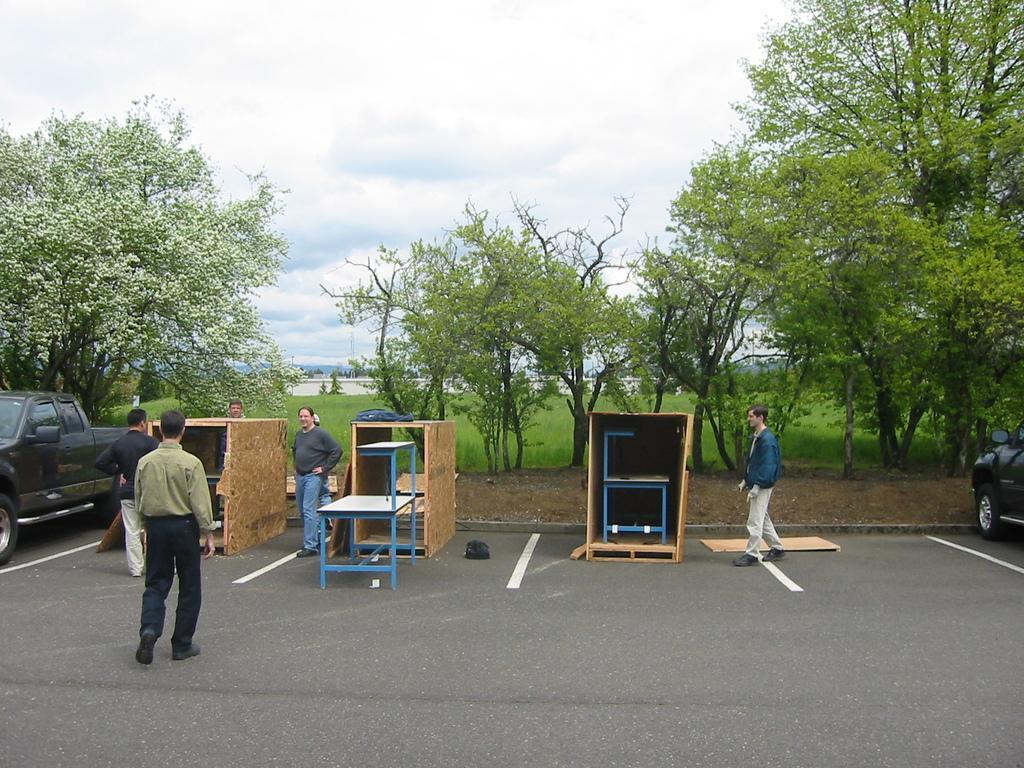In one or two sentences, can you explain what this image depicts? In this picture we can see a few people, vehicles, tables and some objects on the road. We can see grass, plants, trees, other objects and the cloudy sky. 